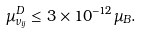Convert formula to latex. <formula><loc_0><loc_0><loc_500><loc_500>\mu ^ { D } _ { \nu _ { i j } } \leq 3 \times 1 0 ^ { - 1 2 } \mu _ { B } .</formula> 